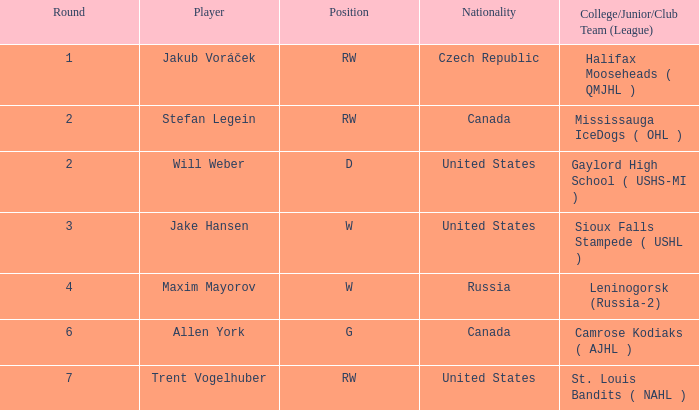What nationality was the round 6 draft pick? Canada. 